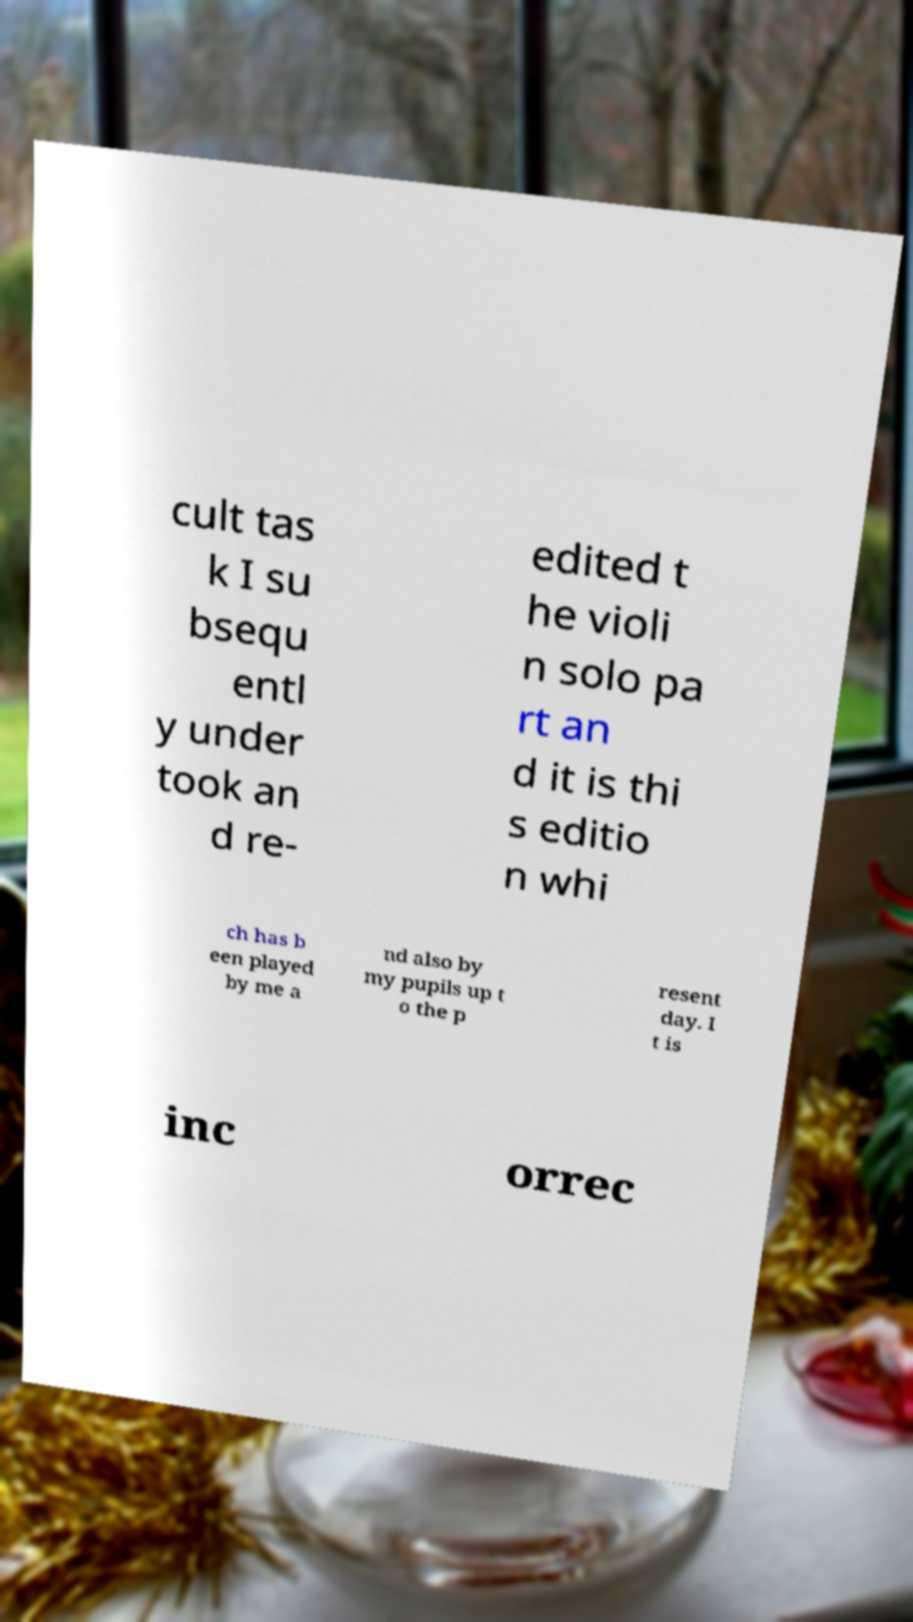There's text embedded in this image that I need extracted. Can you transcribe it verbatim? cult tas k I su bsequ entl y under took an d re- edited t he violi n solo pa rt an d it is thi s editio n whi ch has b een played by me a nd also by my pupils up t o the p resent day. I t is inc orrec 